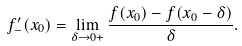Convert formula to latex. <formula><loc_0><loc_0><loc_500><loc_500>f _ { - } ^ { \prime } ( x _ { 0 } ) = \lim _ { \delta \rightarrow 0 + } \frac { f ( x _ { 0 } ) - f ( x _ { 0 } - \delta ) } { \delta } .</formula> 